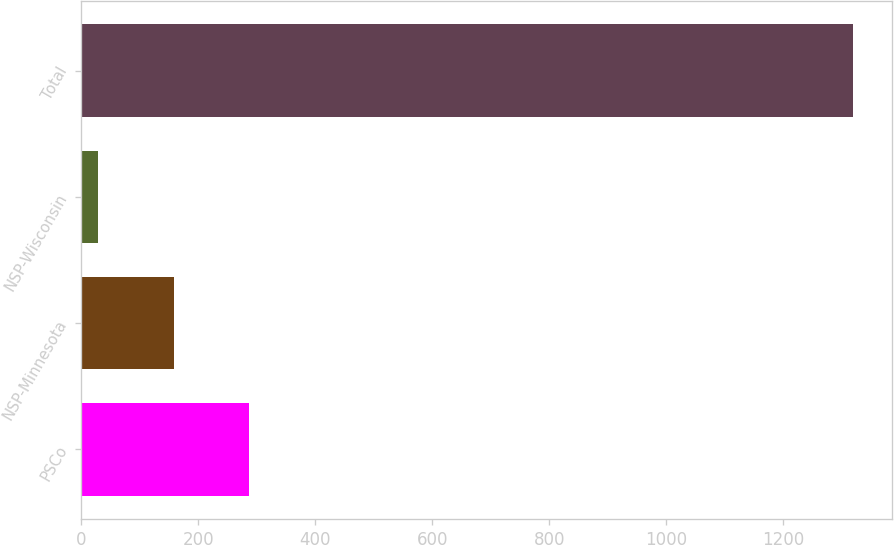<chart> <loc_0><loc_0><loc_500><loc_500><bar_chart><fcel>PSCo<fcel>NSP-Minnesota<fcel>NSP-Wisconsin<fcel>Total<nl><fcel>287<fcel>158<fcel>29<fcel>1319<nl></chart> 